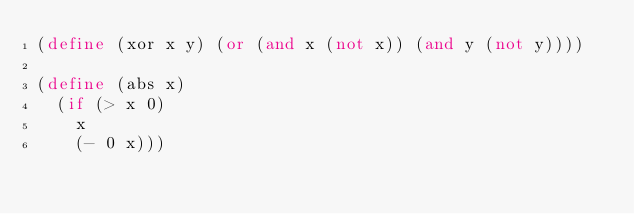<code> <loc_0><loc_0><loc_500><loc_500><_Scheme_>(define (xor x y) (or (and x (not x)) (and y (not y))))

(define (abs x)
  (if (> x 0)
    x
    (- 0 x)))
</code> 